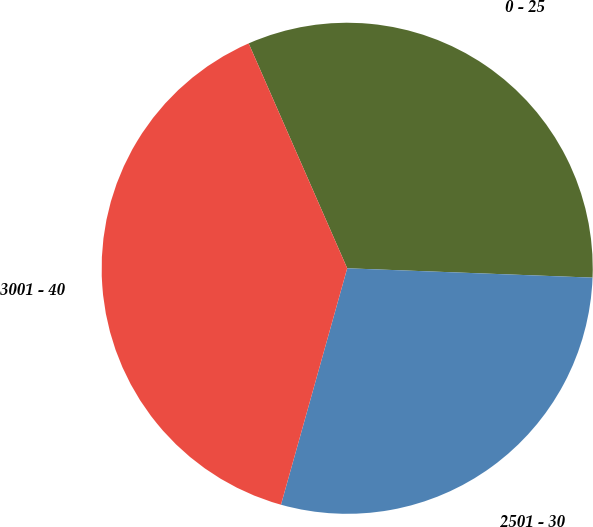Convert chart to OTSL. <chart><loc_0><loc_0><loc_500><loc_500><pie_chart><fcel>0 - 25<fcel>2501 - 30<fcel>3001 - 40<nl><fcel>32.18%<fcel>28.74%<fcel>39.08%<nl></chart> 